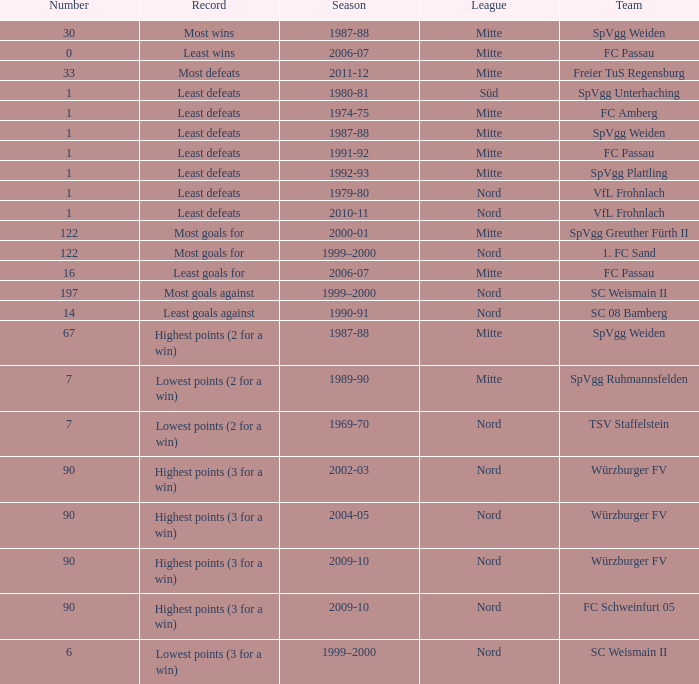What league has a number less than 1? Mitte. 